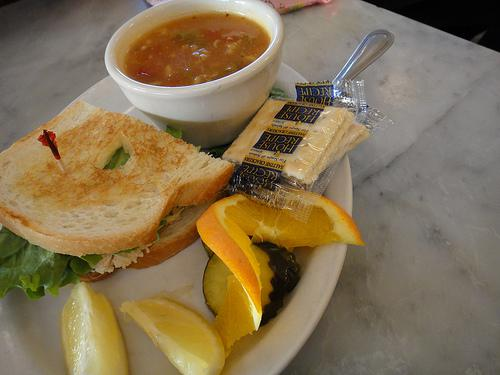Question: what color is the plate?
Choices:
A. Red.
B. White.
C. Black.
D. Blue.
Answer with the letter. Answer: B Question: what material is the table made from?
Choices:
A. Wood.
B. Glass.
C. Marble.
D. Metal.
Answer with the letter. Answer: C Question: what two fruits are on the plate?
Choices:
A. Strawberry, banana.
B. Orange, Lemon.
C. Kiwi, lime.
D. Apple, pear.
Answer with the letter. Answer: B Question: who is standing next to the table?
Choices:
A. Don Knotts.
B. Nobody.
C. Leonardo DiCaprio.
D. Gaby Hoffman.
Answer with the letter. Answer: B Question: what food item is to the right of the soup?
Choices:
A. Salt.
B. Crackers.
C. Cheese.
D. Onion.
Answer with the letter. Answer: B 